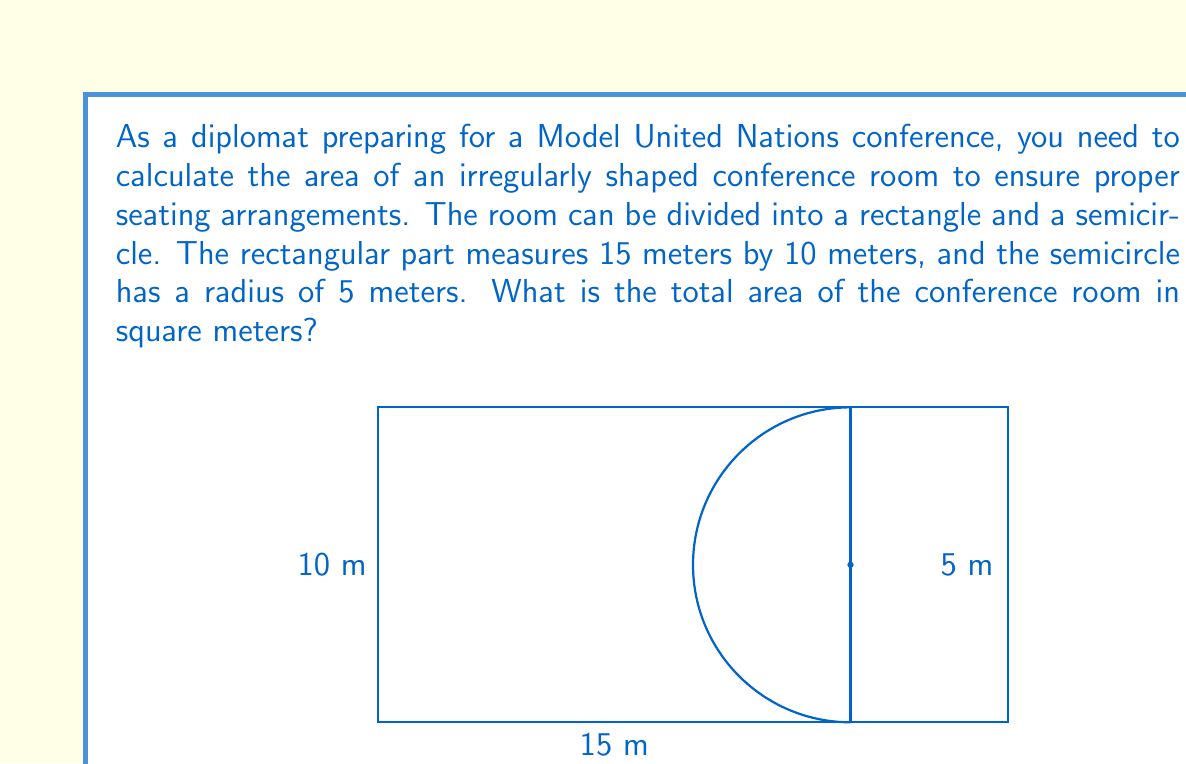What is the answer to this math problem? To solve this problem, we need to calculate the areas of the rectangular part and the semicircular part separately, then add them together.

1. Area of the rectangle:
   $$A_r = l \times w = 15 \text{ m} \times 10 \text{ m} = 150 \text{ m}^2$$

2. Area of the semicircle:
   The formula for the area of a circle is $A = \pi r^2$. Since we only have half a circle, we'll divide this by 2.
   $$A_s = \frac{1}{2} \pi r^2 = \frac{1}{2} \times \pi \times (5 \text{ m})^2 = \frac{25\pi}{2} \text{ m}^2 \approx 39.27 \text{ m}^2$$

3. Total area:
   $$A_{\text{total}} = A_r + A_s = 150 \text{ m}^2 + \frac{25\pi}{2} \text{ m}^2$$

   $$A_{\text{total}} = 150 + \frac{25\pi}{2} \text{ m}^2 \approx 189.27 \text{ m}^2$$

This calculation allows for precise planning of seating arrangements, which is crucial for effective diplomatic discussions in Model United Nations conferences.
Answer: The total area of the conference room is $150 + \frac{25\pi}{2} \text{ m}^2$ or approximately 189.27 m². 